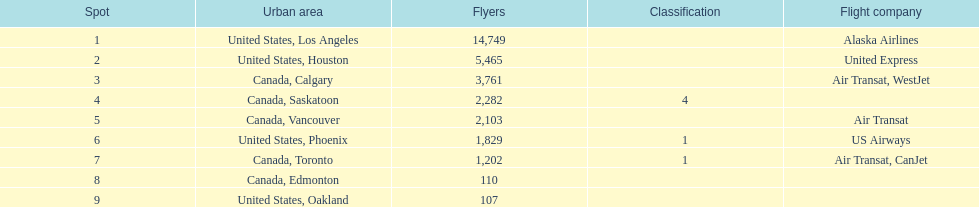The least number of passengers came from which city United States, Oakland. 